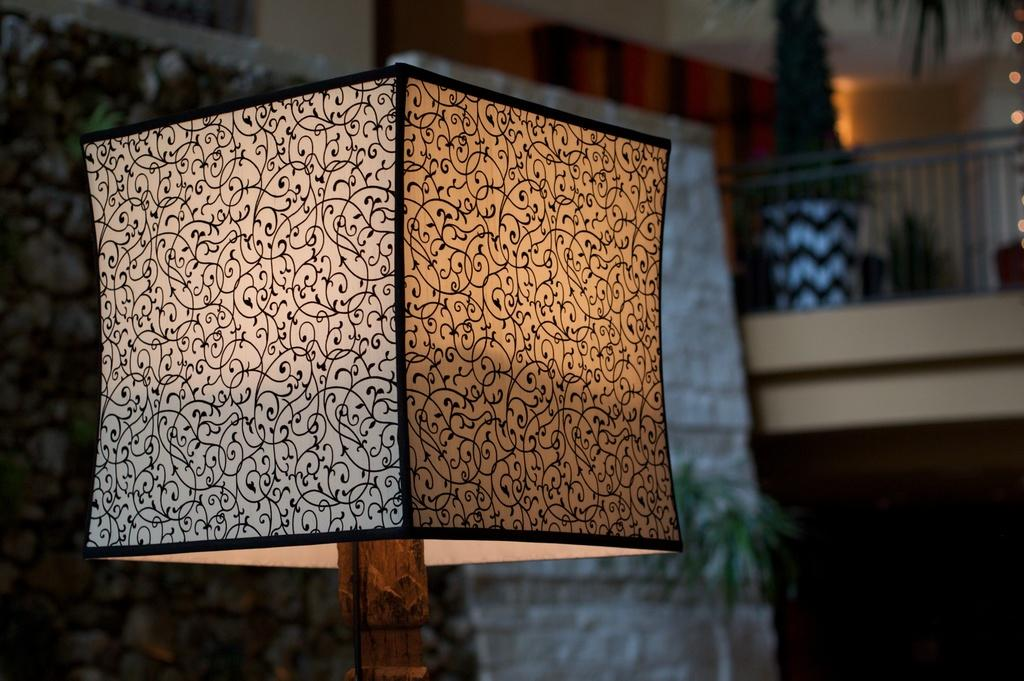What object can be seen in the image that provides light? There is a lamp in the image. How would you describe the appearance of the background in the image? The background of the image is blurry. What type of vegetation is visible in the background of the image? There is a plant in the background of the image. What architectural feature can be seen in the background of the image? There is a fence in the background of the image. What type of smell is emanating from the lamp in the image? The lamp does not emit a smell; it provides light. 